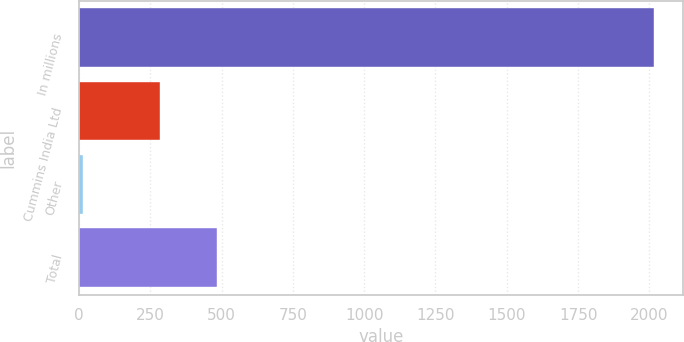Convert chart to OTSL. <chart><loc_0><loc_0><loc_500><loc_500><bar_chart><fcel>In millions<fcel>Cummins India Ltd<fcel>Other<fcel>Total<nl><fcel>2016<fcel>285<fcel>14<fcel>485.2<nl></chart> 